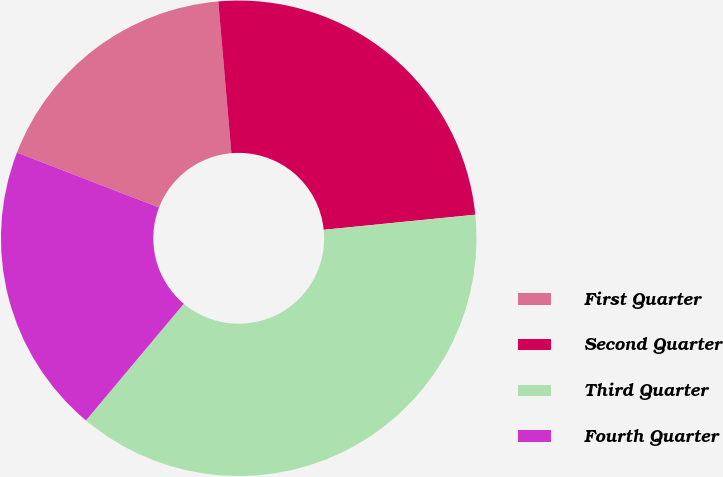<chart> <loc_0><loc_0><loc_500><loc_500><pie_chart><fcel>First Quarter<fcel>Second Quarter<fcel>Third Quarter<fcel>Fourth Quarter<nl><fcel>17.76%<fcel>24.79%<fcel>37.69%<fcel>19.76%<nl></chart> 